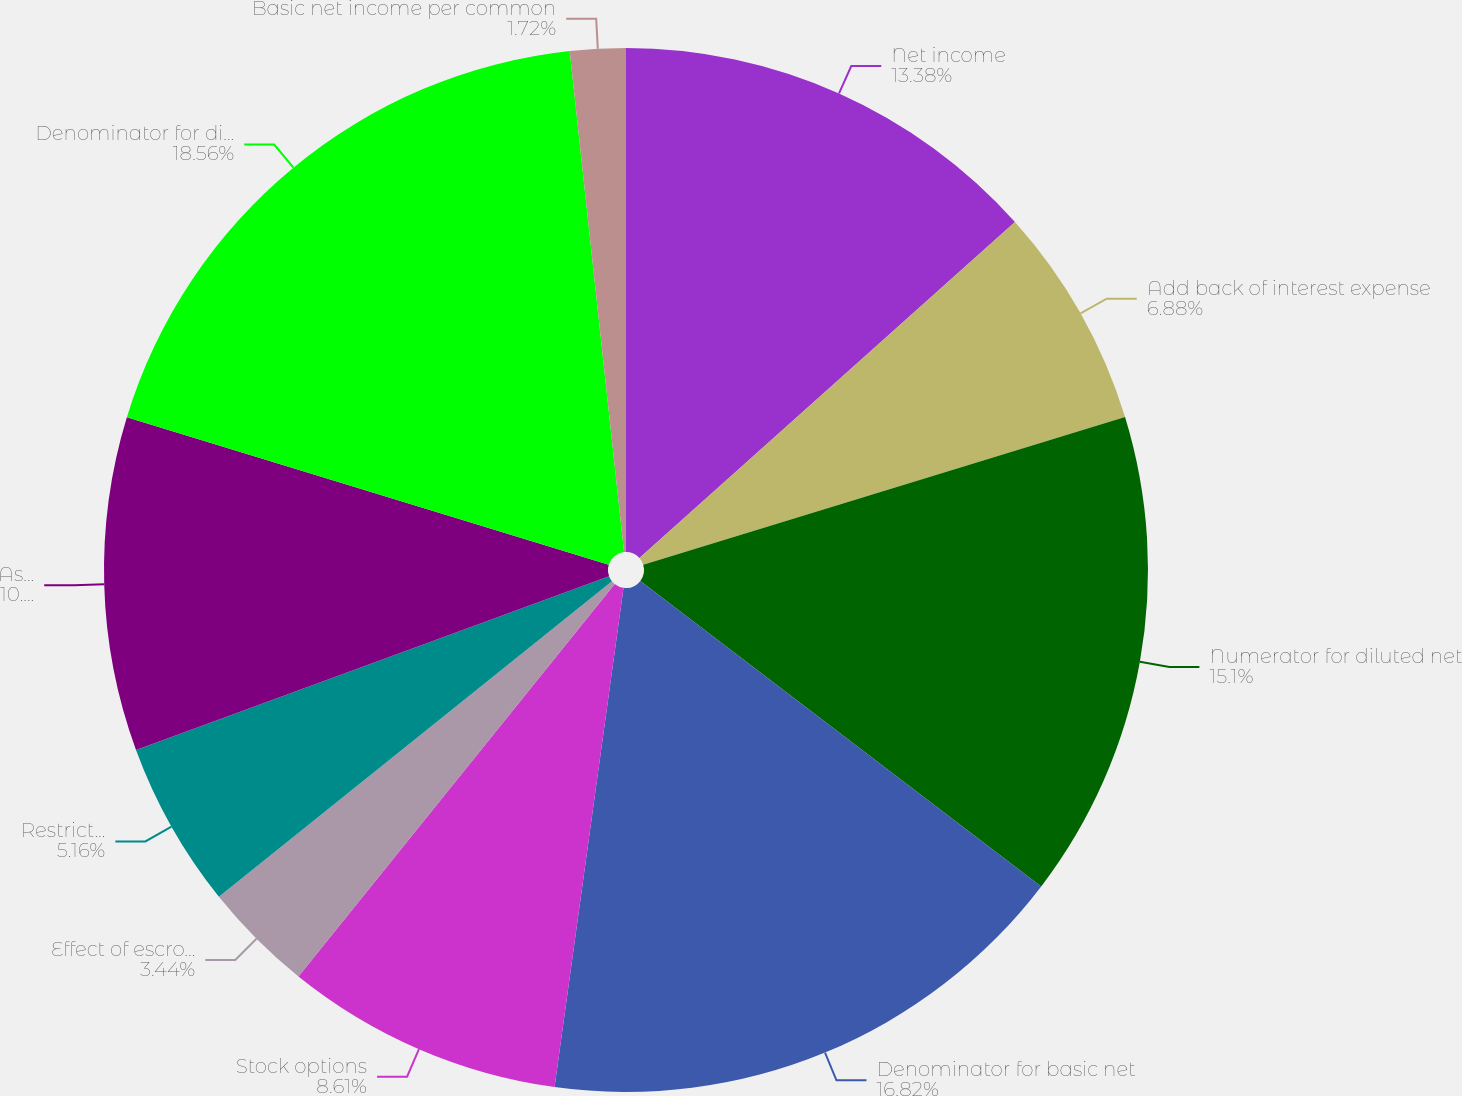<chart> <loc_0><loc_0><loc_500><loc_500><pie_chart><fcel>Net income<fcel>Add back of interest expense<fcel>Numerator for diluted net<fcel>Denominator for basic net<fcel>Stock options<fcel>Effect of escrow contingencies<fcel>Restricted stock units and<fcel>Assumed conversion of 1<fcel>Denominator for diluted net<fcel>Basic net income per common<nl><fcel>13.38%<fcel>6.88%<fcel>15.1%<fcel>16.82%<fcel>8.61%<fcel>3.44%<fcel>5.16%<fcel>10.33%<fcel>18.55%<fcel>1.72%<nl></chart> 